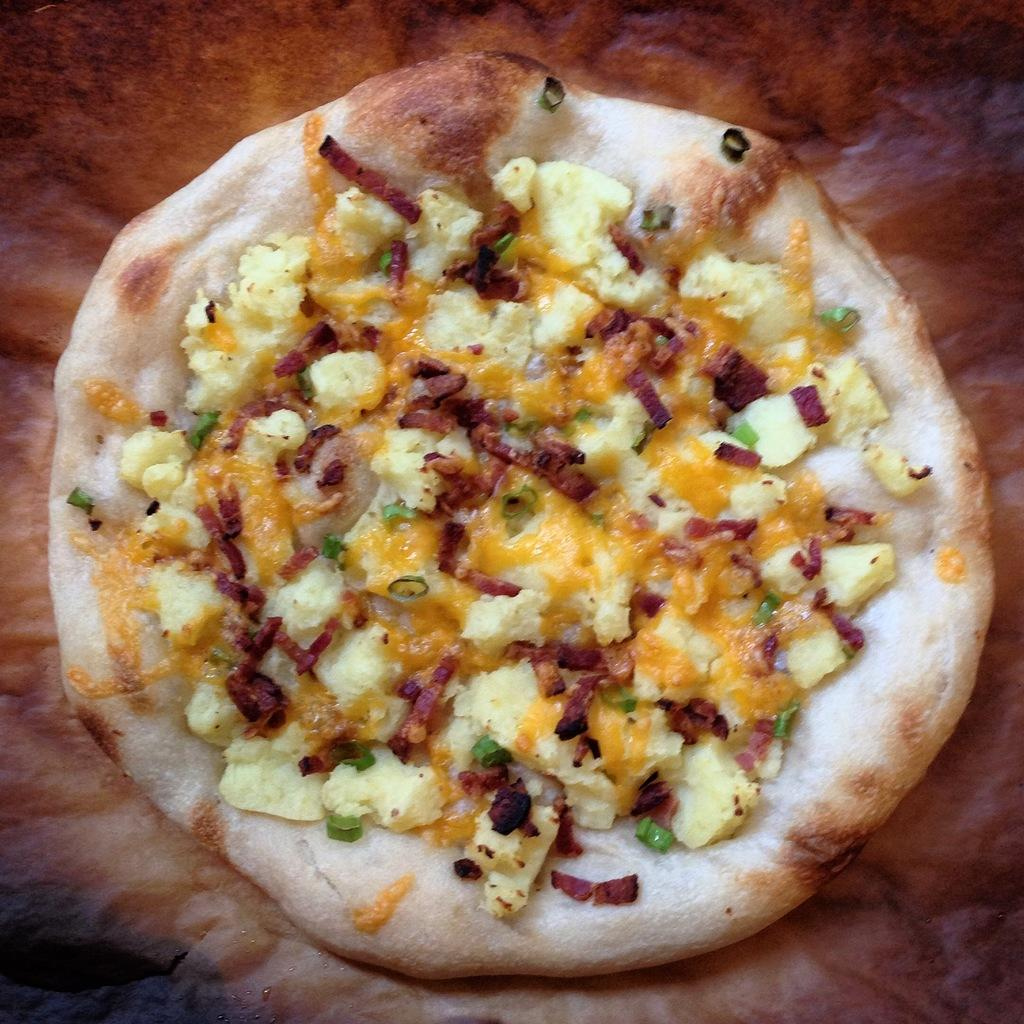What type of food is shown in the image? There is a pizza in the image. Can you describe the background of the image? The background of the image is blurry. What type of pollution can be seen in the image? There is no pollution visible in the image; it only features a pizza and a blurry background. How many muscles are visible on the pizza in the image? There are no muscles present in the image, as it features a pizza and a blurry background. 